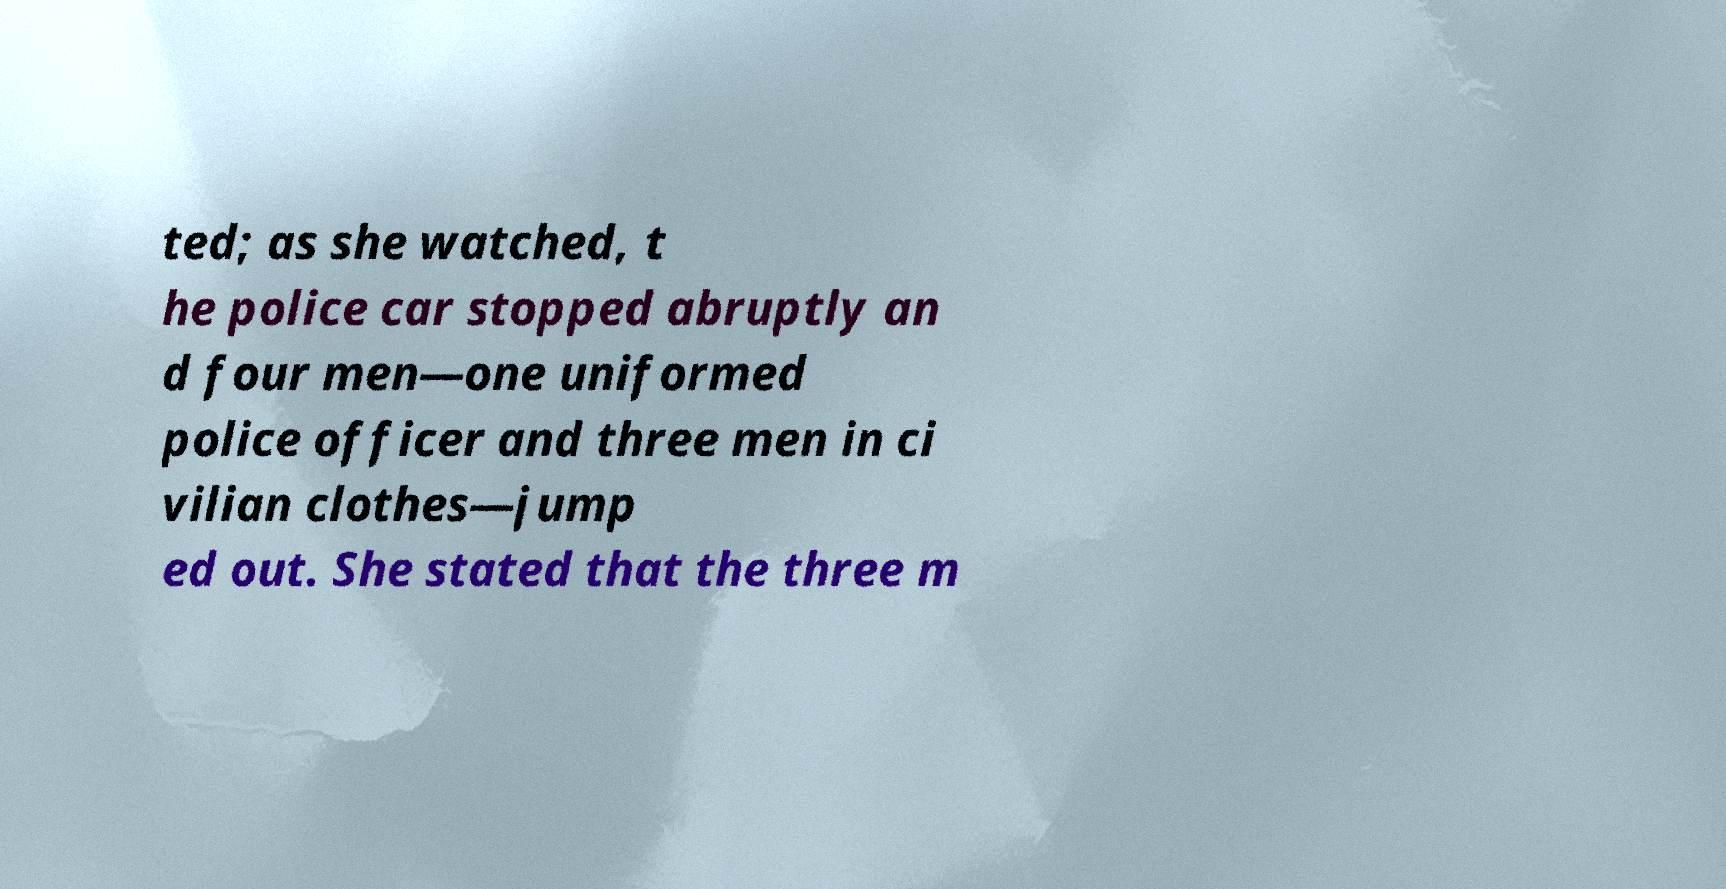Please read and relay the text visible in this image. What does it say? ted; as she watched, t he police car stopped abruptly an d four men—one uniformed police officer and three men in ci vilian clothes—jump ed out. She stated that the three m 